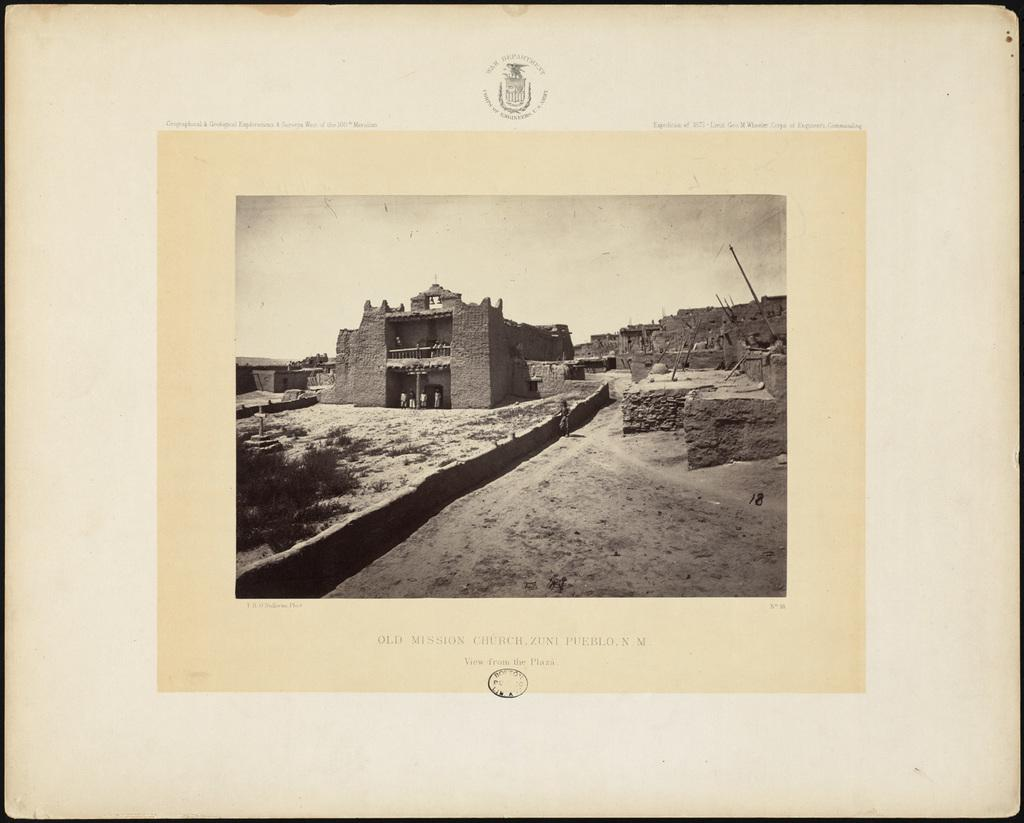Provide a one-sentence caption for the provided image. A sepia colored photograph of the Old Mission Church in Zuni Pueblo, New Mexico. 